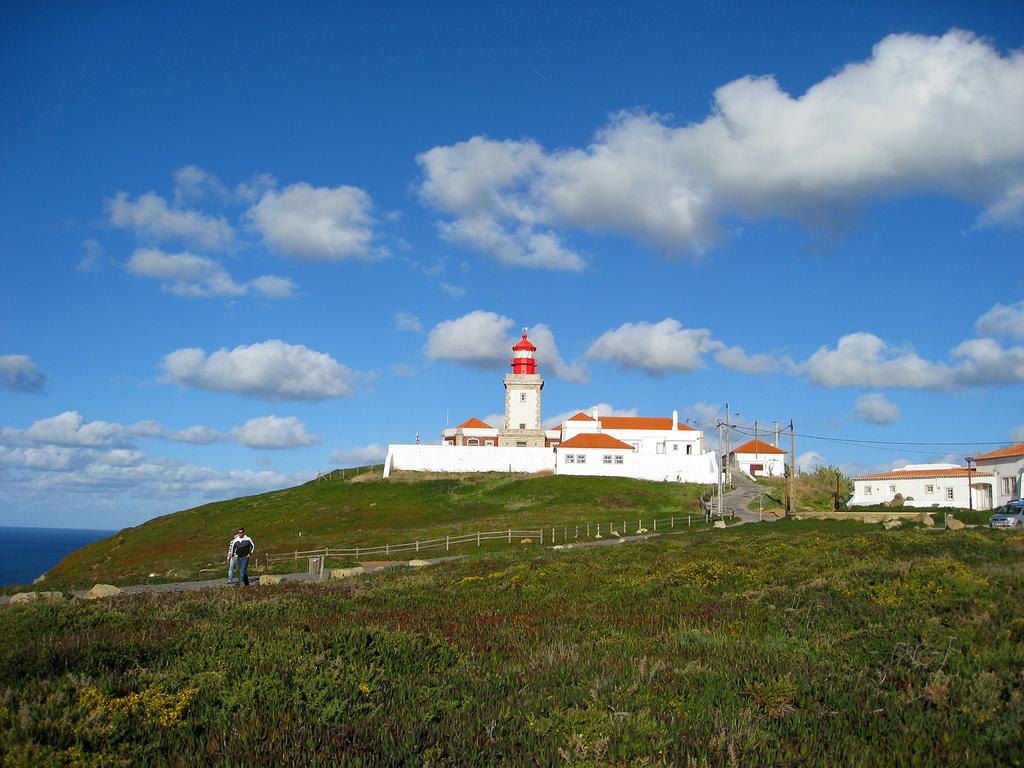What type of structures can be seen in the image? There are houses in the image. What is the color of the grass at the bottom of the image? The grass at the bottom of the image is green. What are the two persons in the image doing? The two persons in the image are walking on the road. What can be seen to the left of the image? There is water visible to the left of the image. What is visible in the sky at the top of the image? There are clouds in the sky at the top of the image. What type of family experience can be seen in the image? There is no family experience depicted in the image; it shows houses, green grass, two persons walking, water, and clouds. How many roses are visible in the image? There are no roses present in the image. 